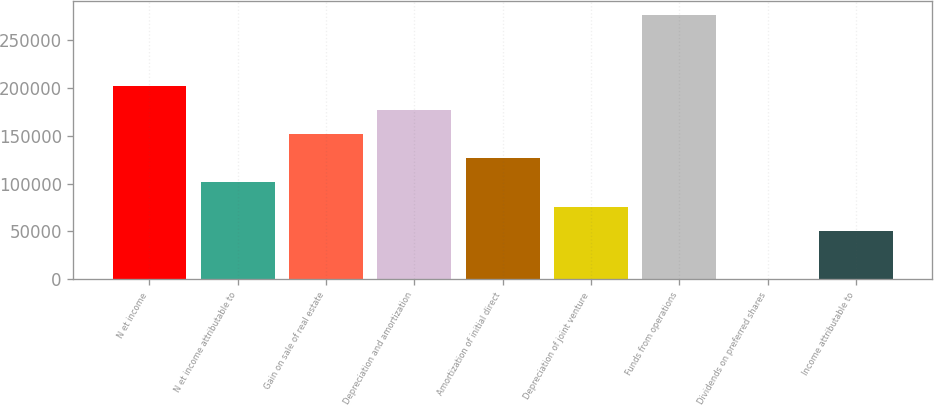Convert chart to OTSL. <chart><loc_0><loc_0><loc_500><loc_500><bar_chart><fcel>N et income<fcel>N et income attributable to<fcel>Gain on sale of real estate<fcel>Depreciation and amortization<fcel>Amortization of initial direct<fcel>Depreciation of joint venture<fcel>Funds from operations<fcel>Dividends on preferred shares<fcel>Income attributable to<nl><fcel>201874<fcel>101207<fcel>151541<fcel>176707<fcel>126374<fcel>76040.8<fcel>276743<fcel>541<fcel>50874.2<nl></chart> 